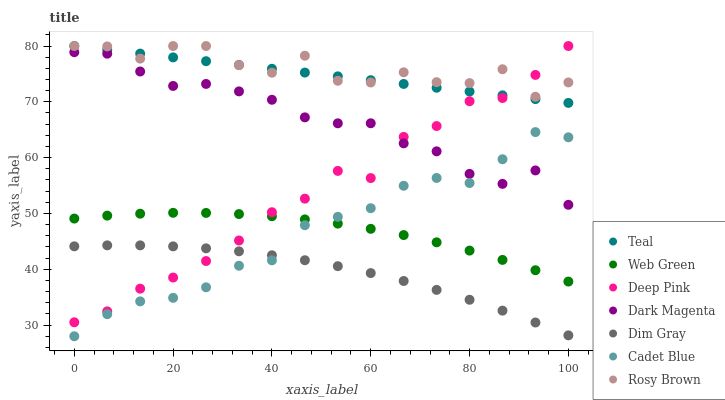Does Dim Gray have the minimum area under the curve?
Answer yes or no. Yes. Does Rosy Brown have the maximum area under the curve?
Answer yes or no. Yes. Does Dark Magenta have the minimum area under the curve?
Answer yes or no. No. Does Dark Magenta have the maximum area under the curve?
Answer yes or no. No. Is Teal the smoothest?
Answer yes or no. Yes. Is Rosy Brown the roughest?
Answer yes or no. Yes. Is Dark Magenta the smoothest?
Answer yes or no. No. Is Dark Magenta the roughest?
Answer yes or no. No. Does Cadet Blue have the lowest value?
Answer yes or no. Yes. Does Dark Magenta have the lowest value?
Answer yes or no. No. Does Teal have the highest value?
Answer yes or no. Yes. Does Dark Magenta have the highest value?
Answer yes or no. No. Is Dark Magenta less than Rosy Brown?
Answer yes or no. Yes. Is Rosy Brown greater than Web Green?
Answer yes or no. Yes. Does Teal intersect Deep Pink?
Answer yes or no. Yes. Is Teal less than Deep Pink?
Answer yes or no. No. Is Teal greater than Deep Pink?
Answer yes or no. No. Does Dark Magenta intersect Rosy Brown?
Answer yes or no. No. 